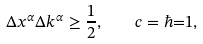Convert formula to latex. <formula><loc_0><loc_0><loc_500><loc_500>\Delta x ^ { \alpha } \Delta k ^ { \alpha } \geq \frac { 1 } { 2 } , \quad c = \hbar { = } 1 ,</formula> 